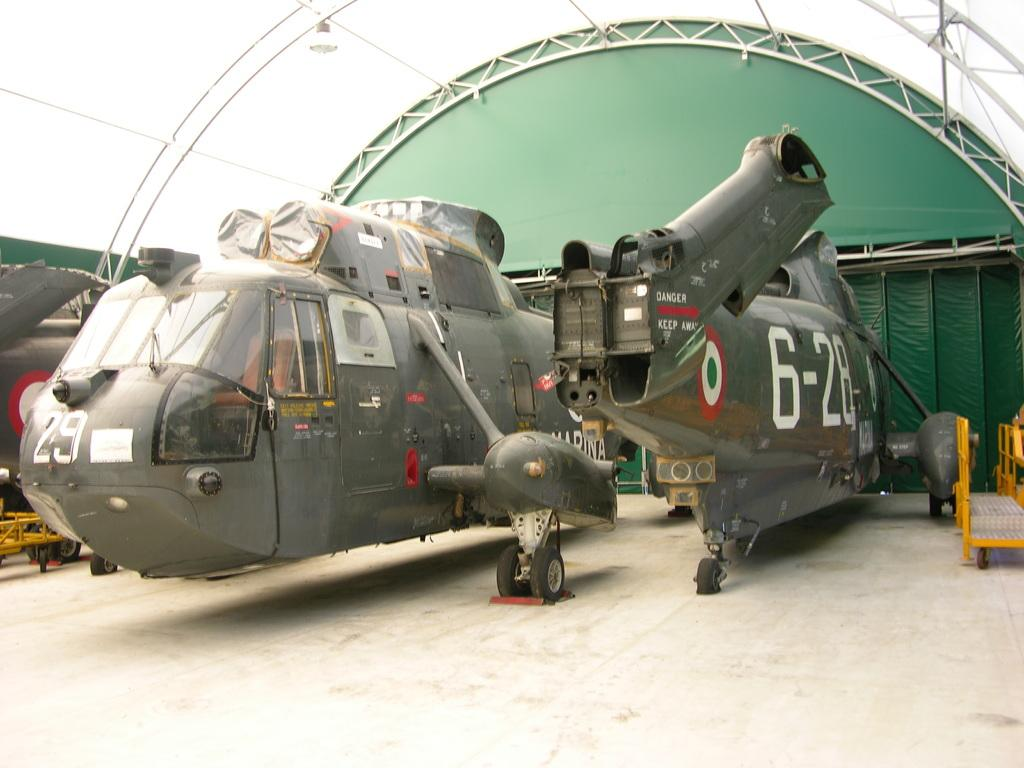<image>
Describe the image concisely. A jet with the numbers 6-28 is in the hangar 